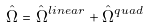<formula> <loc_0><loc_0><loc_500><loc_500>\hat { \Omega } = { \hat { \Omega } } ^ { l i n e a r } + { \hat { \Omega } } ^ { q u a d }</formula> 